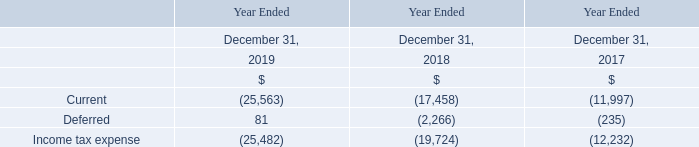The components of the provision for income tax expense are as follows:
Included in the Company's current income tax expense are provisions for uncertain tax positions relating to freight taxes. The Company does not presently anticipate that its provisions for these uncertain tax positions will significantly increase in the next 12 months; however, this is dependent on the jurisdictions of the trading activity of its vessels.
The Company reviews its freight tax obligations on a regular basis and may update its assessment of its tax positions based on available information at the time. Such information may include legal advice as to the applicability of freight taxes in relevant jurisdictions. Freight tax regulations are subject to change and interpretation; therefore, the amounts recorded by the Company may change accordingly. The tax years 2008 through 2019 remain open to examination by some of the major jurisdictions in which the Company is subject to tax.
What is included in current income tax expense? Included in the company's current income tax expense are provisions for uncertain tax positions relating to freight taxes. What will determine the tax positions in the next 12 months? The company does not presently anticipate that its provisions for these uncertain tax positions will significantly increase in the next 12 months; however, this is dependent on the jurisdictions of the trading activity of its vessels. Which tax years are open to examination by jurisdictions? The tax years 2008 through 2019 remain open to examination by some of the major jurisdictions in which the company is subject to tax. What is the increase/ (decrease) in Current from December 31, 2019 to December 31, 2018?
Answer scale should be: million. 25,563-17,458
Answer: 8105. What is the increase/ (decrease) in Deferred from December 31, 2019 to December 31, 2018?
Answer scale should be: million. 81-2,266
Answer: -2185. What is the increase/ (decrease) in Income tax expense from December 31, 2019 to December 31, 2018?
Answer scale should be: million. 25,482-19,724
Answer: 5758. 